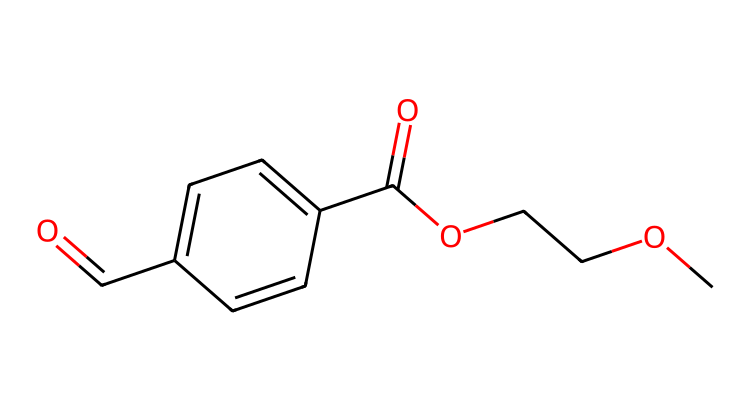What is the name of this chemical? The SMILES representation corresponds to polyethylene terephthalate, which is derived from the combination of terephthalic acid and ethylene glycol.
Answer: polyethylene terephthalate How many carbon atoms are in the structure? By analyzing the SMILES, we count the carbon atoms represented. There are 10 carbon atoms in the structure.
Answer: 10 What type of polymer does this chemical represent? Polyethylene terephthalate is classified as a polyester because of the ester functional groups present in its structure.
Answer: polyester What functional group is present in this chemical? The chemical includes ester group (-COO-) and carboxylic acid group (-COOH), indicating the presence of both functional groups in its structure.
Answer: ester How many oxygen atoms are present in this chemical? In the structure, counting the oxygen atoms from the ester and carboxylic acid functionalities results in a total of 4 oxygen atoms.
Answer: 4 What characteristic does this polymer impart for trophy construction? Polyethylene terephthalate is known for its durability and resistance to impact, which makes it suitable for constructing trophies that need to be long-lasting.
Answer: durability 